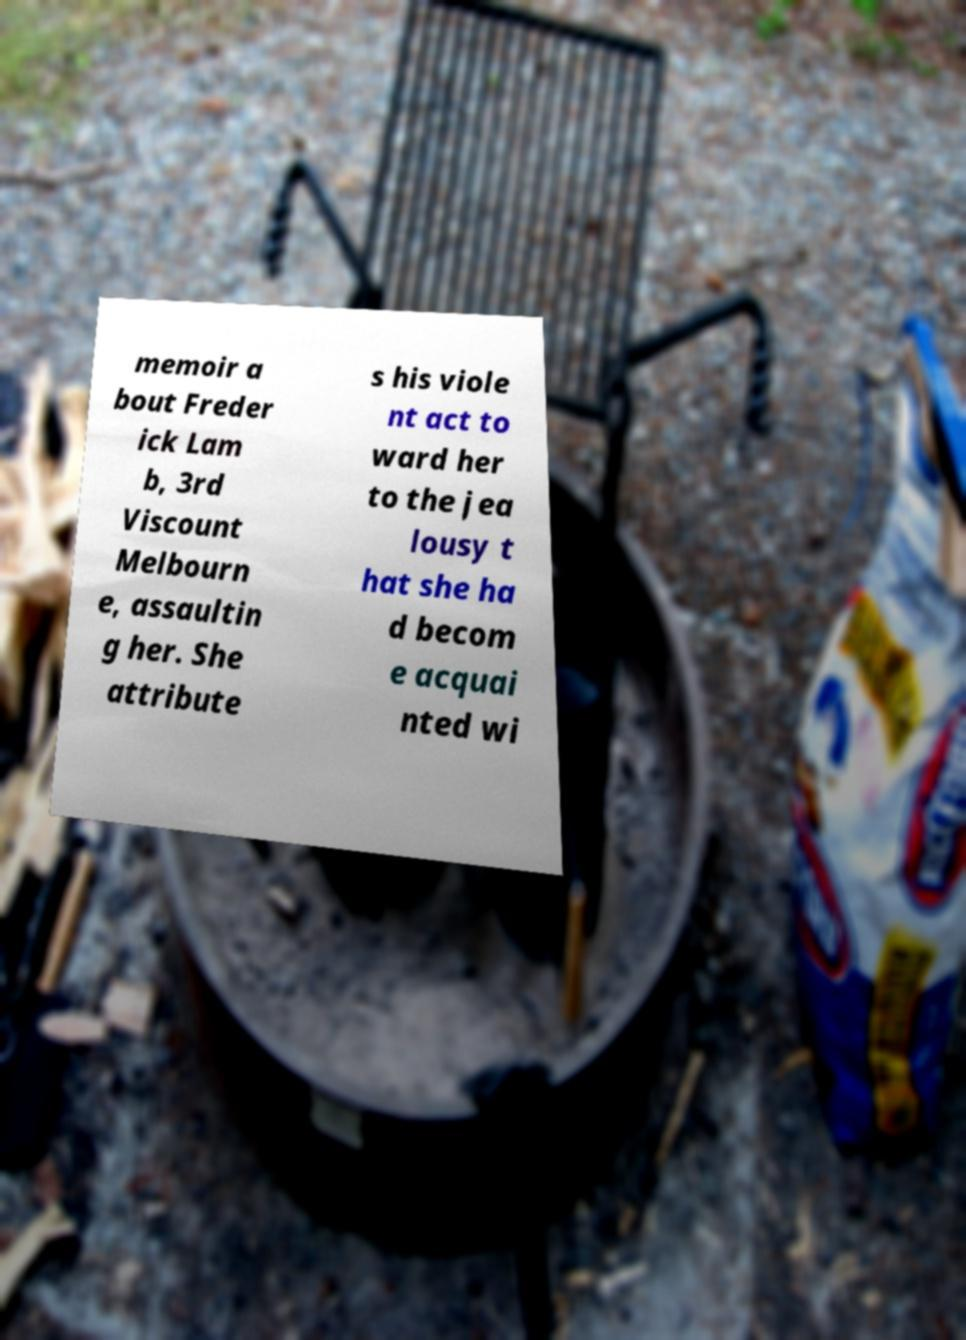For documentation purposes, I need the text within this image transcribed. Could you provide that? memoir a bout Freder ick Lam b, 3rd Viscount Melbourn e, assaultin g her. She attribute s his viole nt act to ward her to the jea lousy t hat she ha d becom e acquai nted wi 